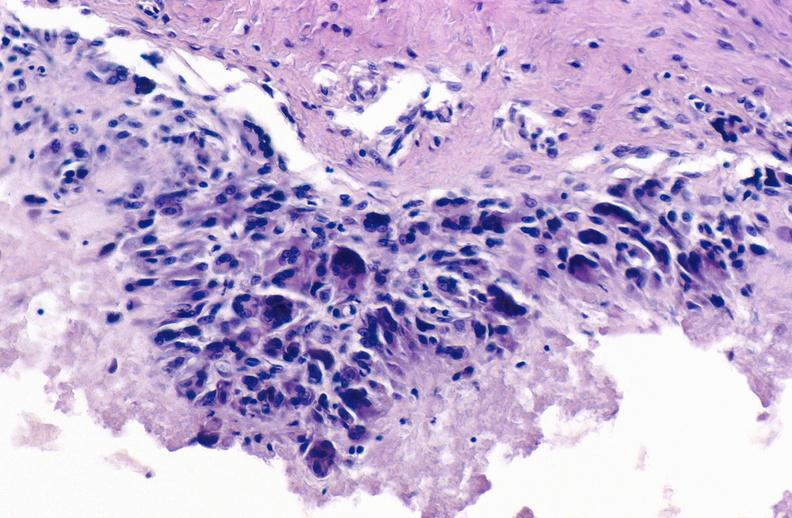what is present?
Answer the question using a single word or phrase. Joints 